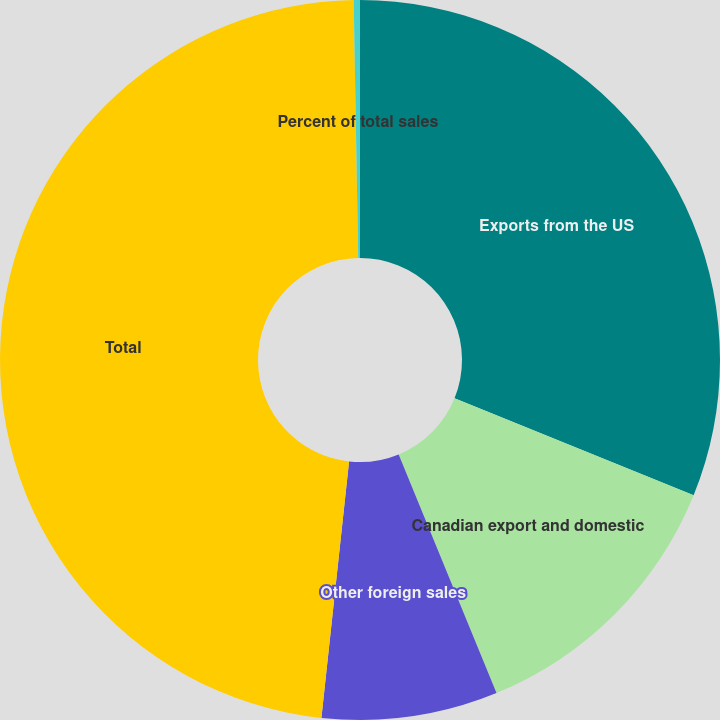<chart> <loc_0><loc_0><loc_500><loc_500><pie_chart><fcel>Exports from the US<fcel>Canadian export and domestic<fcel>Other foreign sales<fcel>Total<fcel>Percent of total sales<nl><fcel>31.13%<fcel>12.68%<fcel>7.9%<fcel>48.01%<fcel>0.28%<nl></chart> 